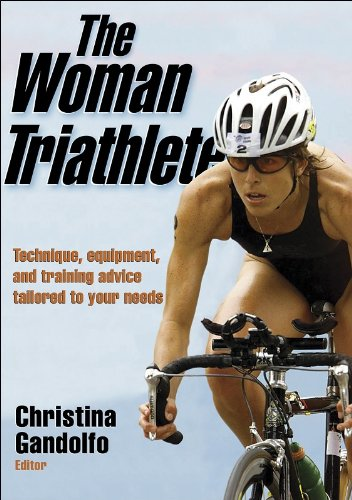What is the title of this book? The title of this book is 'The Woman Triathlete'. It focuses on empowering female athletes by providing in-depth knowledge about the sport of triathlon. 